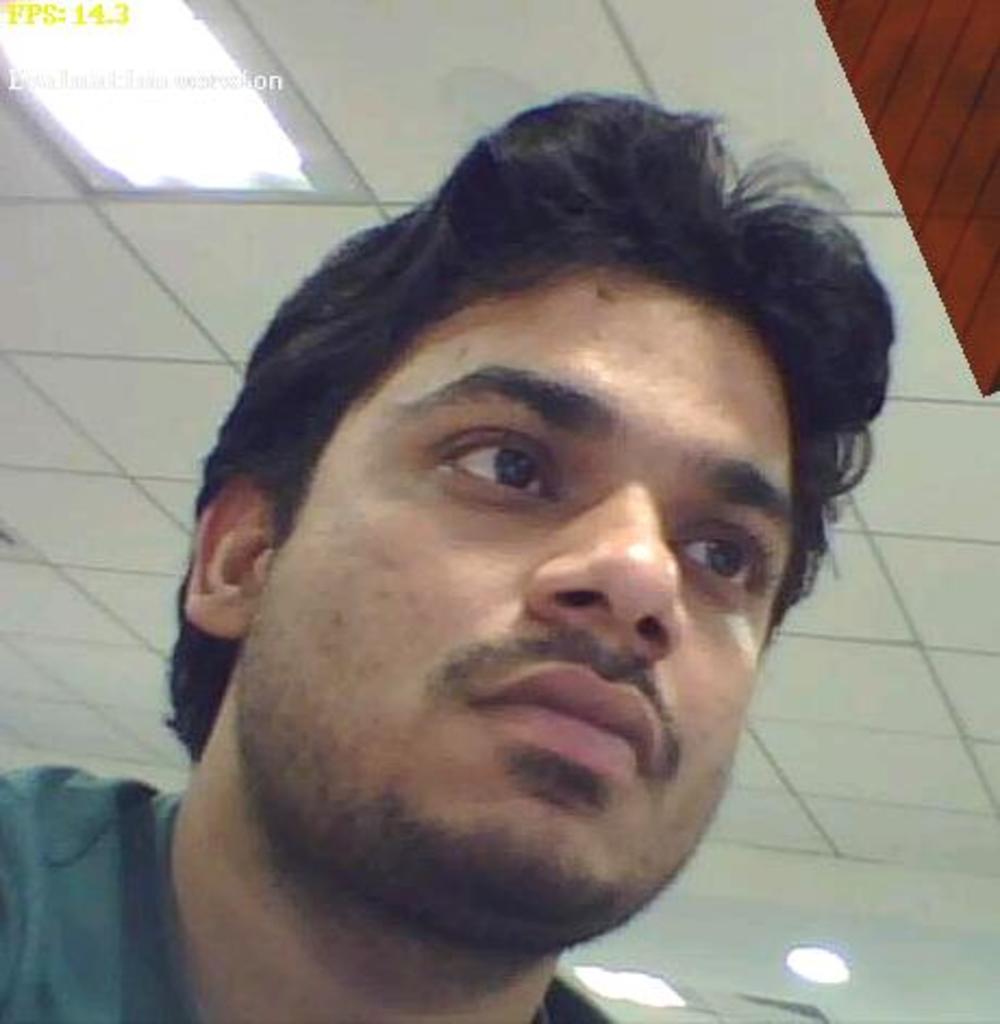Describe this image in one or two sentences. In this picture I can see there is a man sitting and he is wearing a t-shirt and looking at right side and there are lights attached to the ceiling. 